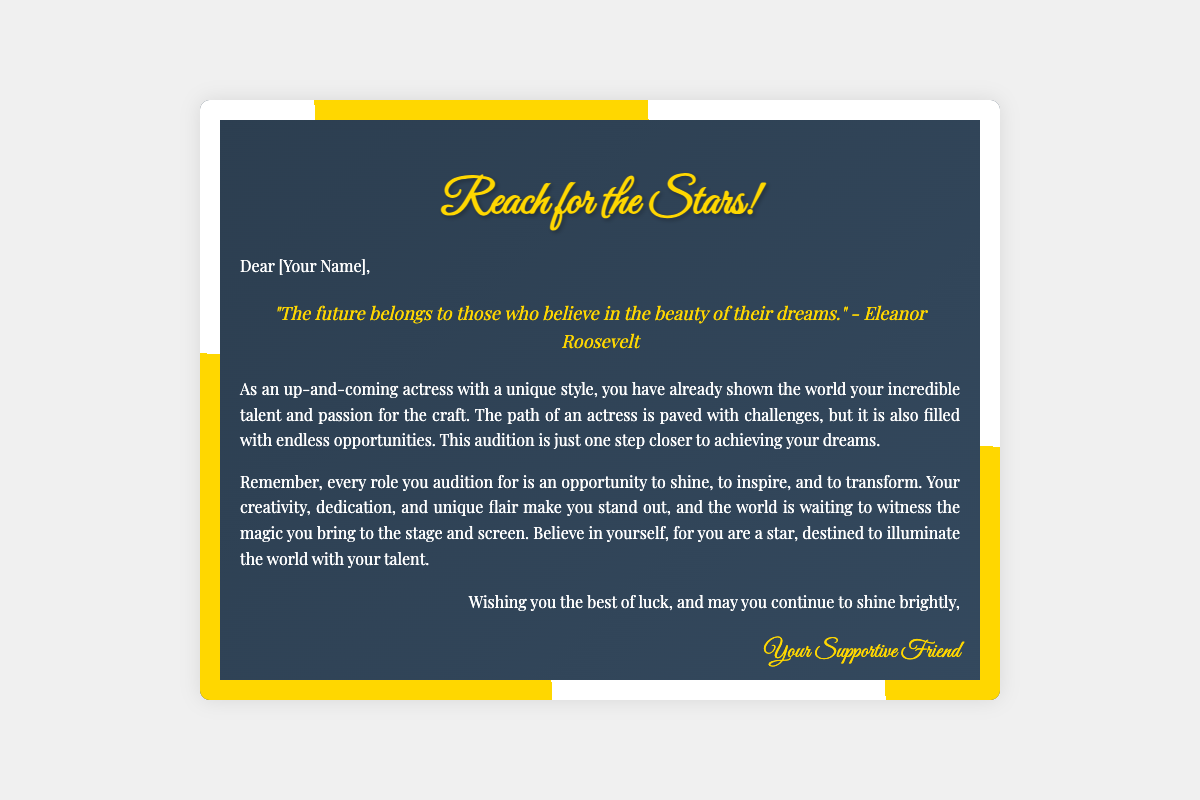What is the title of the card? The title of the card is displayed prominently at the top and is "Reach for the Stars!".
Answer: Reach for the Stars! Who is the message addressed to? The message begins with "Dear [Your Name]," indicating it is addressed to the reader or the person receiving the card.
Answer: [Your Name] Which quote is included in the card? The quote included in the card is stated in a specific section and is attributed to Eleanor Roosevelt.
Answer: "The future belongs to those who believe in the beauty of their dreams." What is the color of the header text? The header text is designed with a particular color that makes it stand out, which is specifically noted as golden.
Answer: #ffd700 What are the two themes used in the card's design? The design features a combination of artistic styles that can be categorized; one is a monochrome theme and the other is art deco.
Answer: monochrome, art deco How many stars are there on the card? The document specifies a total count of decorative elements that resemble stars placed within the card.
Answer: 4 What does the message encourage the reader to do? The message contains motivational language that aims to uplift and encourage the reader in their audition journey, inviting them to embrace their creativity and talent.
Answer: Shine, believe in yourself Who is signing off the message? The closing part of the card reveals the identity of the person who is sending the encouraging words, as noted in the signature.
Answer: Your Supportive Friend 